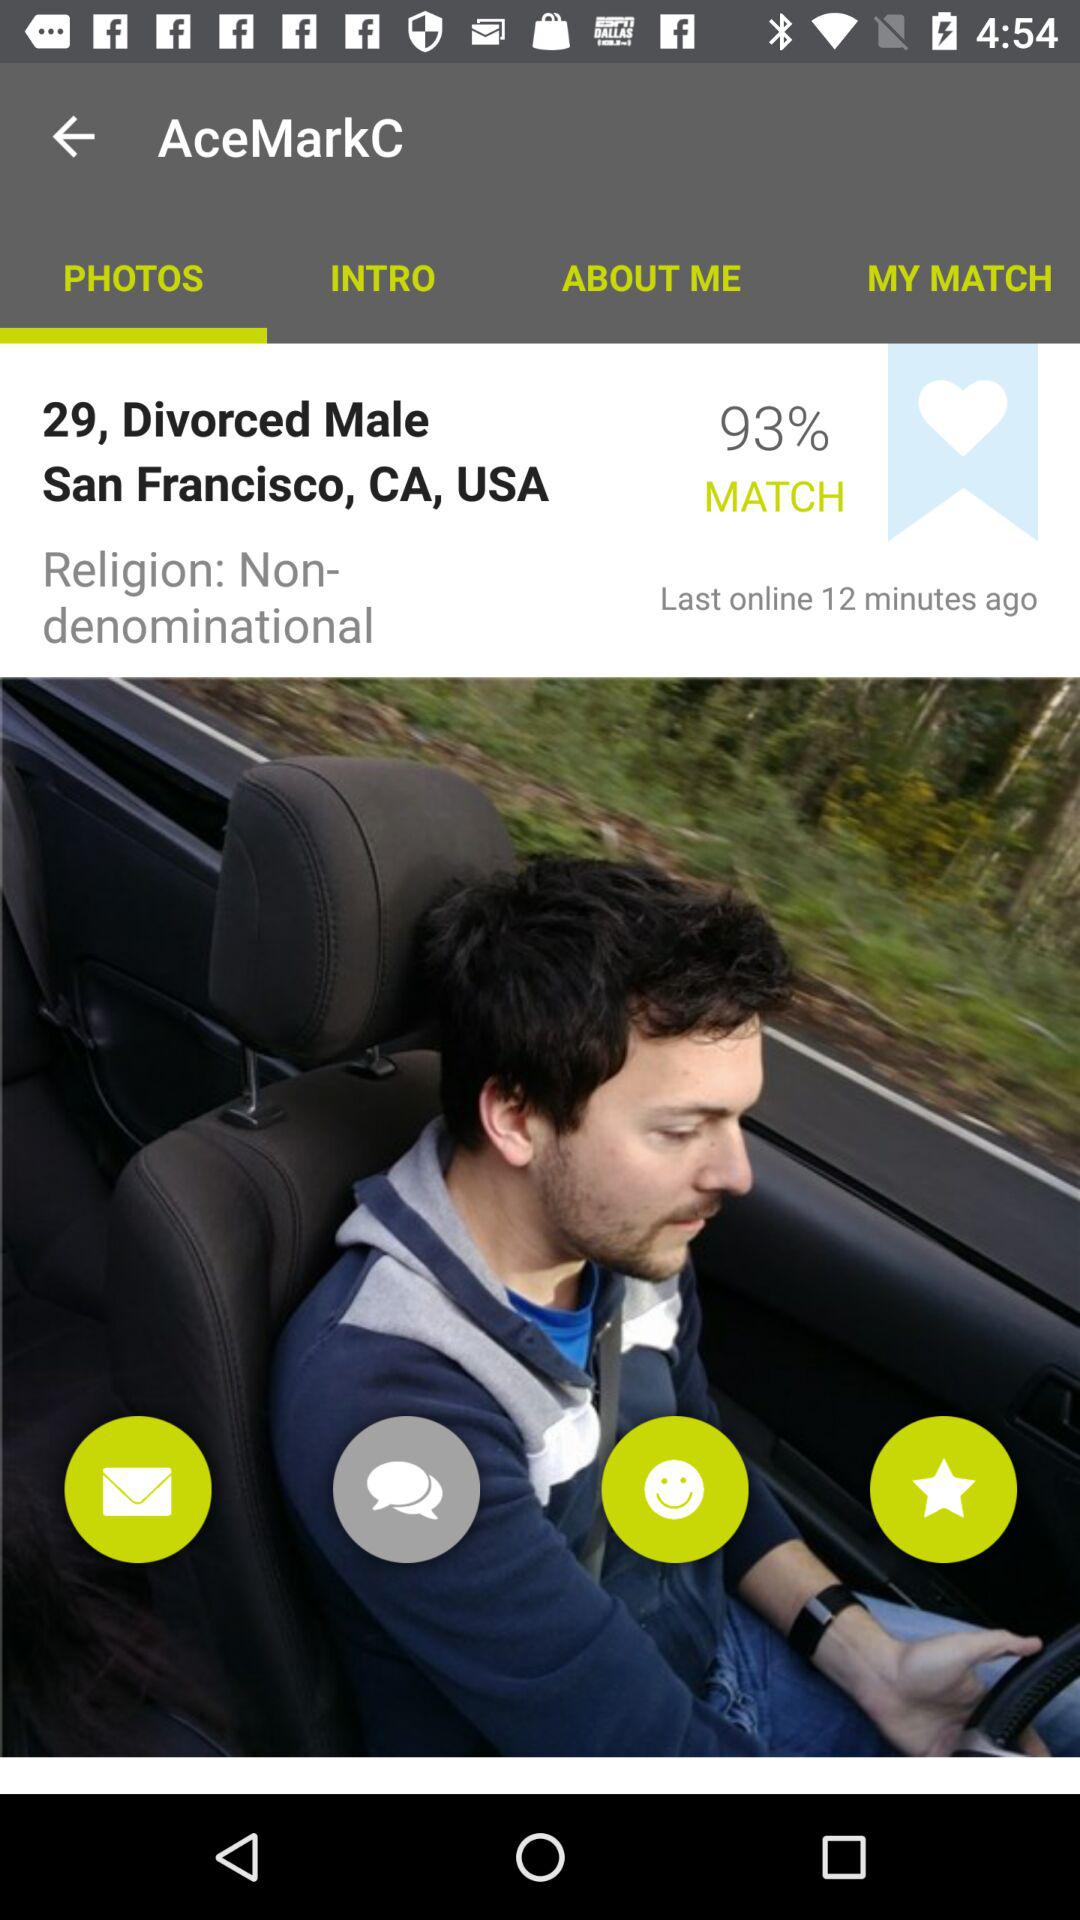What is the given gender? The gender is male. 